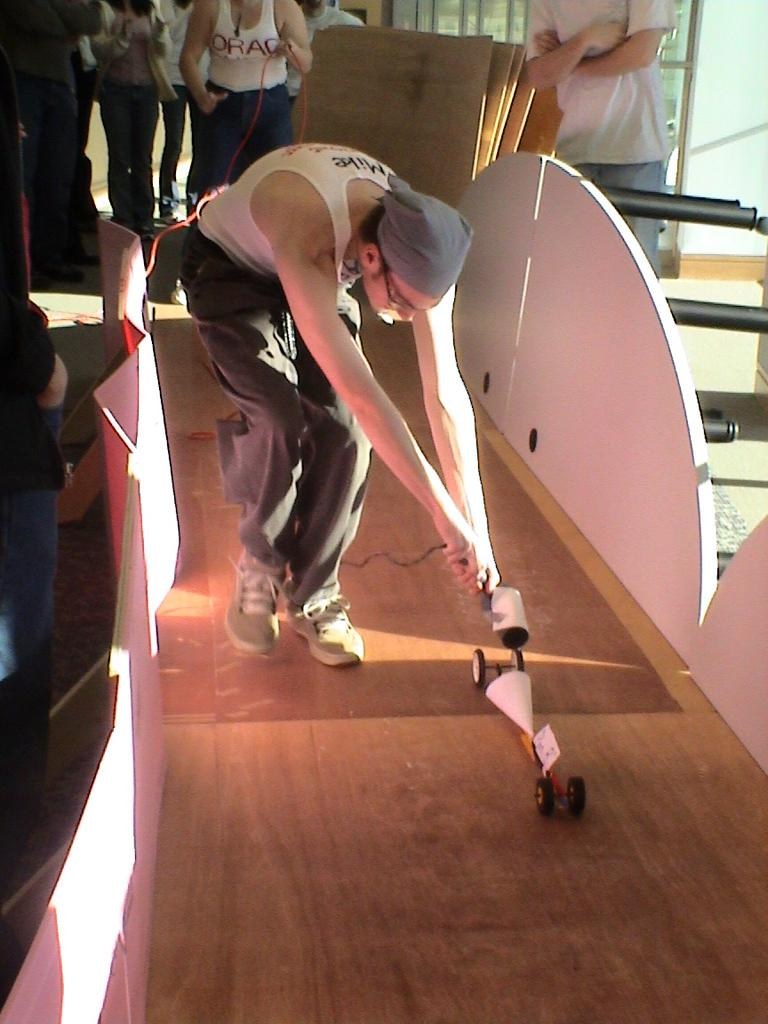How many people are in the image? There are people in the image, but the exact number is not specified. What is one person doing in the image? One person is playing with an object on the floor. What type of objects can be seen in the image? Boards and poles are visible in the image. What is the background of the image? There is a wall in the image. What type of pig can be seen fearing the shoe in the image? There is no pig or shoe present in the image, so this scenario cannot be observed. 